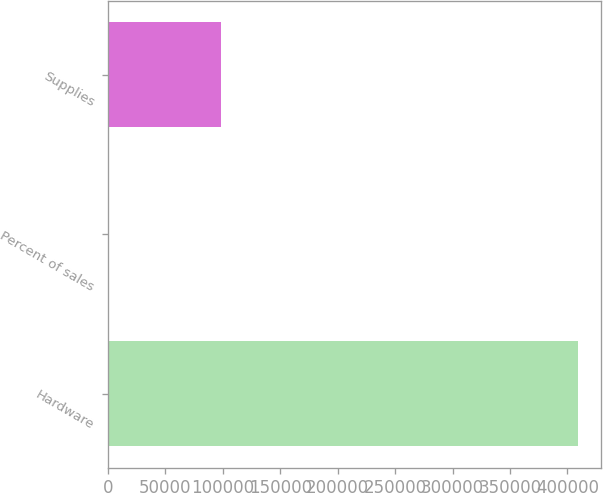Convert chart to OTSL. <chart><loc_0><loc_0><loc_500><loc_500><bar_chart><fcel>Hardware<fcel>Percent of sales<fcel>Supplies<nl><fcel>409144<fcel>76.3<fcel>98556<nl></chart> 